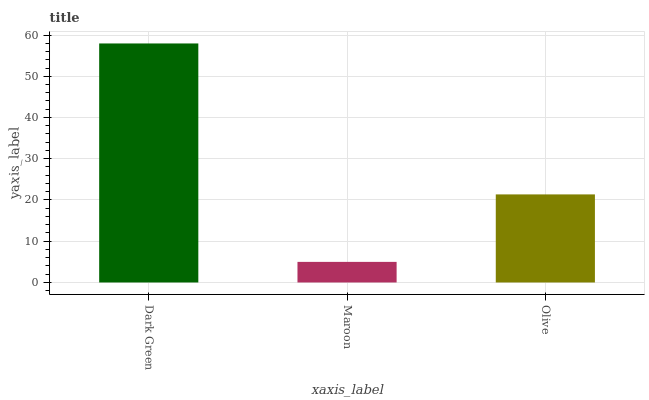Is Maroon the minimum?
Answer yes or no. Yes. Is Dark Green the maximum?
Answer yes or no. Yes. Is Olive the minimum?
Answer yes or no. No. Is Olive the maximum?
Answer yes or no. No. Is Olive greater than Maroon?
Answer yes or no. Yes. Is Maroon less than Olive?
Answer yes or no. Yes. Is Maroon greater than Olive?
Answer yes or no. No. Is Olive less than Maroon?
Answer yes or no. No. Is Olive the high median?
Answer yes or no. Yes. Is Olive the low median?
Answer yes or no. Yes. Is Maroon the high median?
Answer yes or no. No. Is Dark Green the low median?
Answer yes or no. No. 